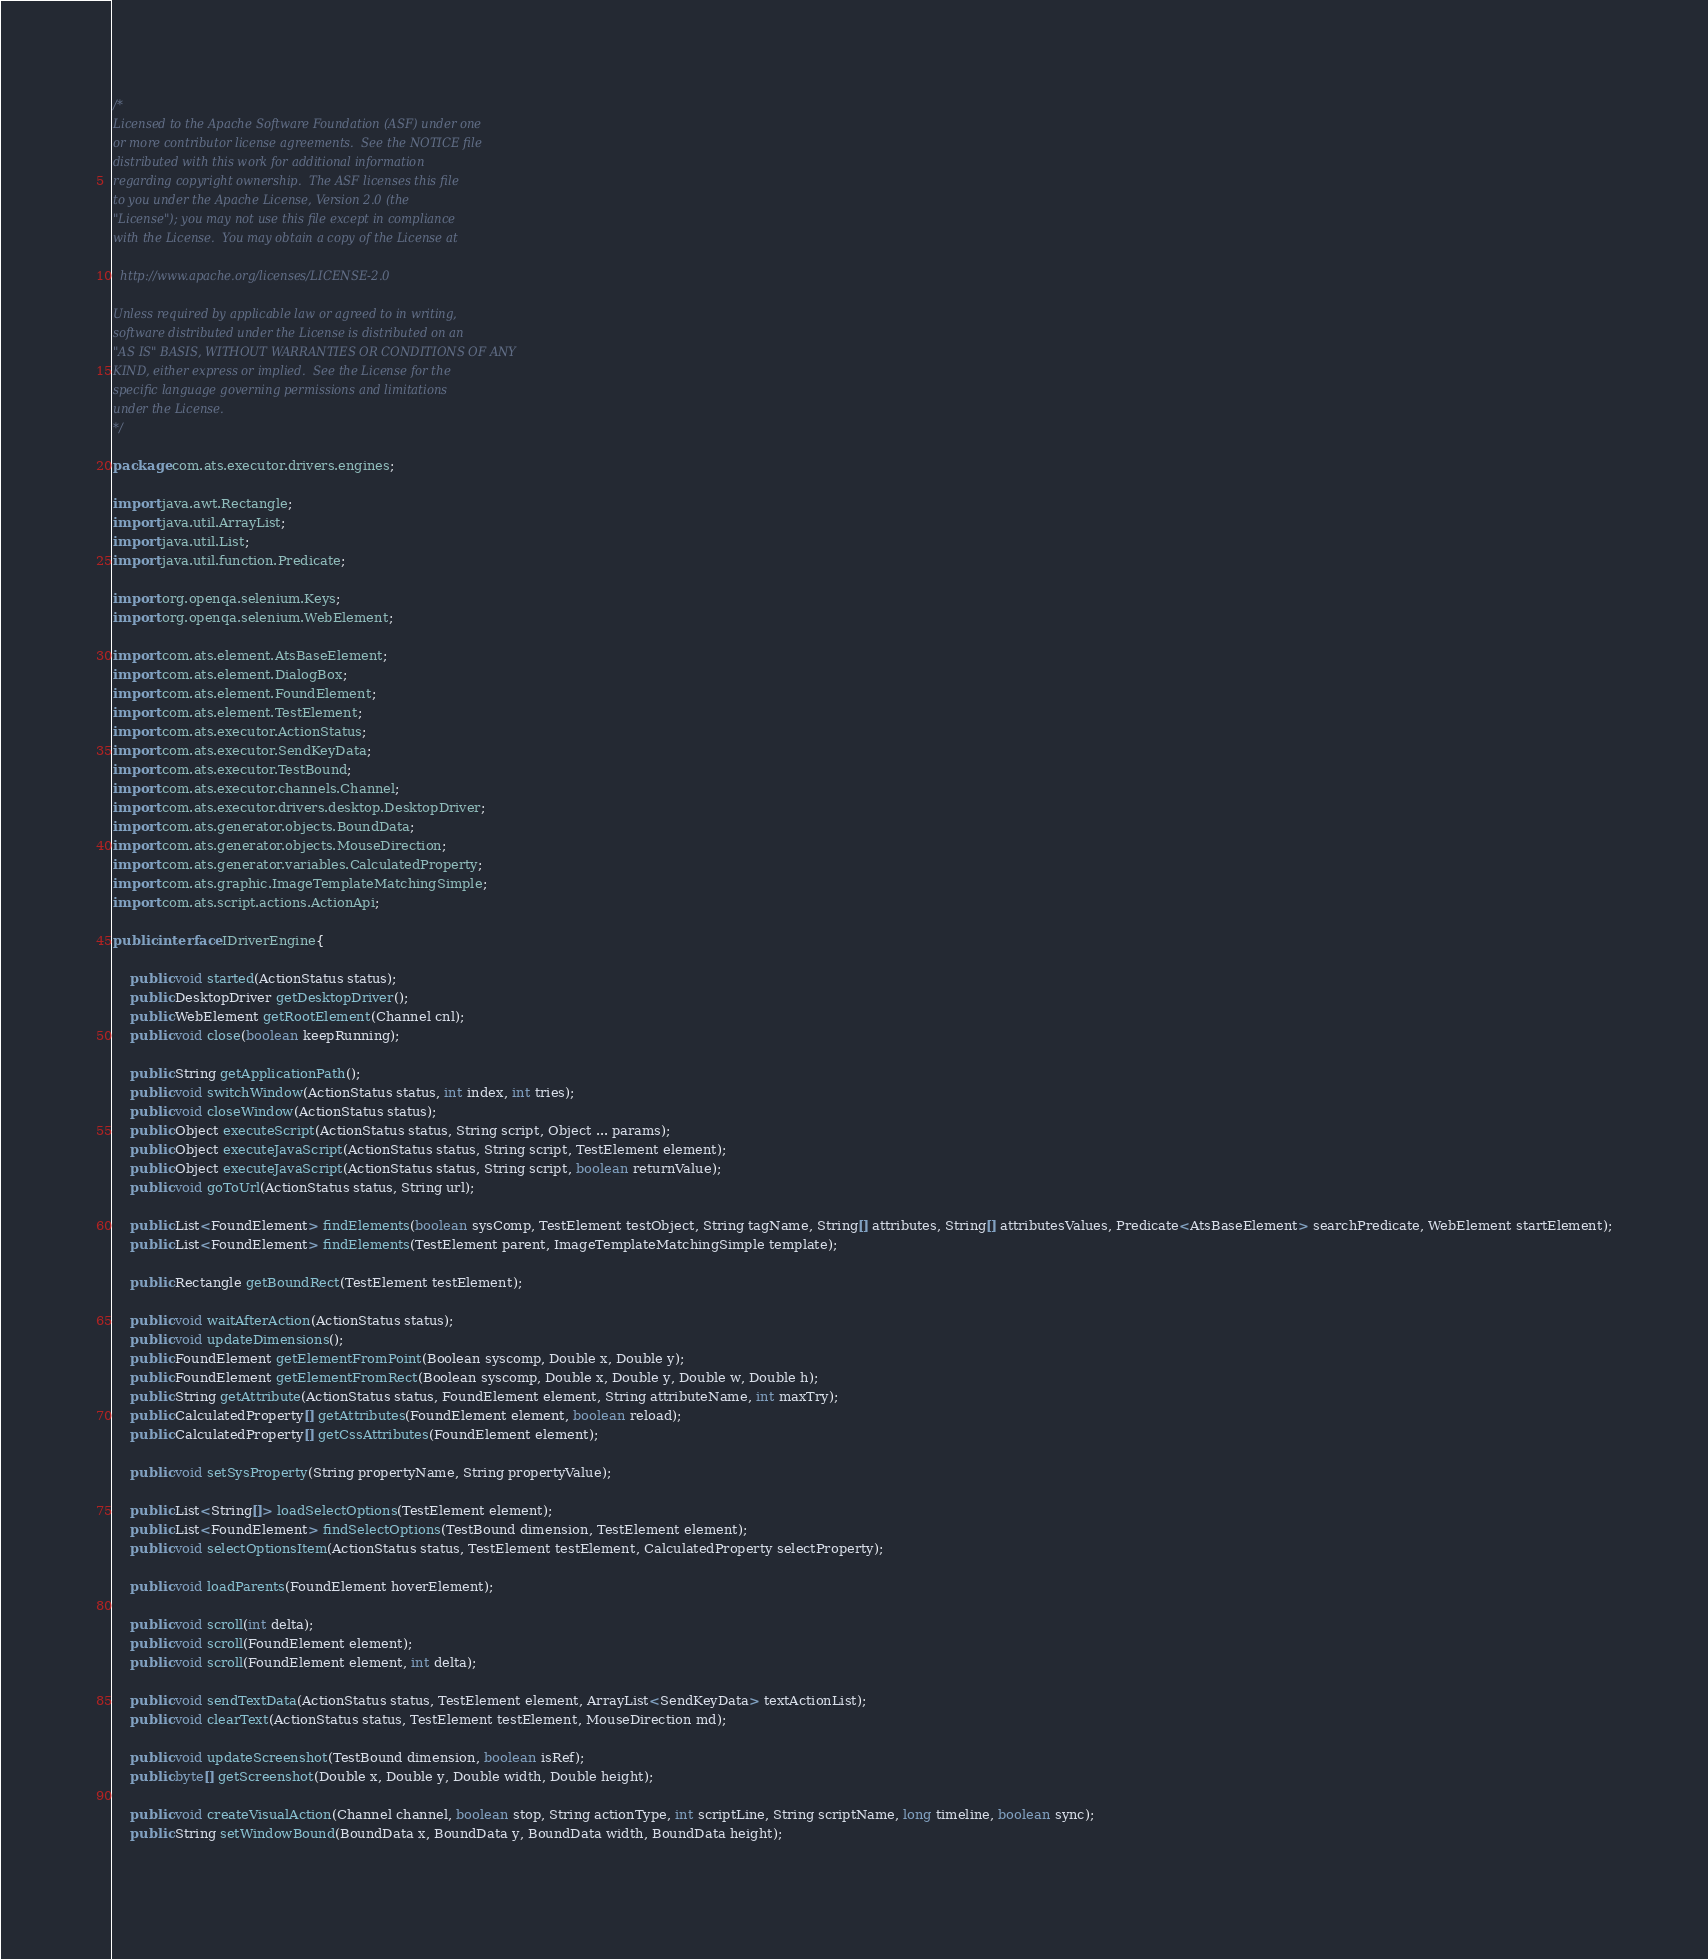Convert code to text. <code><loc_0><loc_0><loc_500><loc_500><_Java_>/*
Licensed to the Apache Software Foundation (ASF) under one
or more contributor license agreements.  See the NOTICE file
distributed with this work for additional information
regarding copyright ownership.  The ASF licenses this file
to you under the Apache License, Version 2.0 (the
"License"); you may not use this file except in compliance
with the License.  You may obtain a copy of the License at

  http://www.apache.org/licenses/LICENSE-2.0

Unless required by applicable law or agreed to in writing,
software distributed under the License is distributed on an
"AS IS" BASIS, WITHOUT WARRANTIES OR CONDITIONS OF ANY
KIND, either express or implied.  See the License for the
specific language governing permissions and limitations
under the License.
*/

package com.ats.executor.drivers.engines;

import java.awt.Rectangle;
import java.util.ArrayList;
import java.util.List;
import java.util.function.Predicate;

import org.openqa.selenium.Keys;
import org.openqa.selenium.WebElement;

import com.ats.element.AtsBaseElement;
import com.ats.element.DialogBox;
import com.ats.element.FoundElement;
import com.ats.element.TestElement;
import com.ats.executor.ActionStatus;
import com.ats.executor.SendKeyData;
import com.ats.executor.TestBound;
import com.ats.executor.channels.Channel;
import com.ats.executor.drivers.desktop.DesktopDriver;
import com.ats.generator.objects.BoundData;
import com.ats.generator.objects.MouseDirection;
import com.ats.generator.variables.CalculatedProperty;
import com.ats.graphic.ImageTemplateMatchingSimple;
import com.ats.script.actions.ActionApi;

public interface IDriverEngine{
	
	public void started(ActionStatus status);
	public DesktopDriver getDesktopDriver();
	public WebElement getRootElement(Channel cnl);
	public void close(boolean keepRunning);

	public String getApplicationPath();
	public void switchWindow(ActionStatus status, int index, int tries);
	public void closeWindow(ActionStatus status);
	public Object executeScript(ActionStatus status, String script, Object ... params);
	public Object executeJavaScript(ActionStatus status, String script, TestElement element);
	public Object executeJavaScript(ActionStatus status, String script, boolean returnValue);
	public void goToUrl(ActionStatus status, String url);
	
	public List<FoundElement> findElements(boolean sysComp, TestElement testObject, String tagName, String[] attributes, String[] attributesValues, Predicate<AtsBaseElement> searchPredicate, WebElement startElement);
	public List<FoundElement> findElements(TestElement parent, ImageTemplateMatchingSimple template);
	
	public Rectangle getBoundRect(TestElement testElement);
	
	public void waitAfterAction(ActionStatus status);
	public void updateDimensions();
	public FoundElement getElementFromPoint(Boolean syscomp, Double x, Double y);
	public FoundElement getElementFromRect(Boolean syscomp, Double x, Double y, Double w, Double h);
	public String getAttribute(ActionStatus status, FoundElement element, String attributeName, int maxTry);
	public CalculatedProperty[] getAttributes(FoundElement element, boolean reload);
	public CalculatedProperty[] getCssAttributes(FoundElement element);
	
	public void setSysProperty(String propertyName, String propertyValue);
	
	public List<String[]> loadSelectOptions(TestElement element);
	public List<FoundElement> findSelectOptions(TestBound dimension, TestElement element);
	public void selectOptionsItem(ActionStatus status, TestElement testElement, CalculatedProperty selectProperty);
	
	public void loadParents(FoundElement hoverElement);
	
	public void scroll(int delta);
	public void scroll(FoundElement element);
	public void scroll(FoundElement element, int delta);

	public void sendTextData(ActionStatus status, TestElement element, ArrayList<SendKeyData> textActionList);
	public void clearText(ActionStatus status, TestElement testElement, MouseDirection md);
	
	public void updateScreenshot(TestBound dimension, boolean isRef);
	public byte[] getScreenshot(Double x, Double y, Double width, Double height);
	
	public void createVisualAction(Channel channel, boolean stop, String actionType, int scriptLine, String scriptName, long timeline, boolean sync);
	public String setWindowBound(BoundData x, BoundData y, BoundData width, BoundData height);
	</code> 